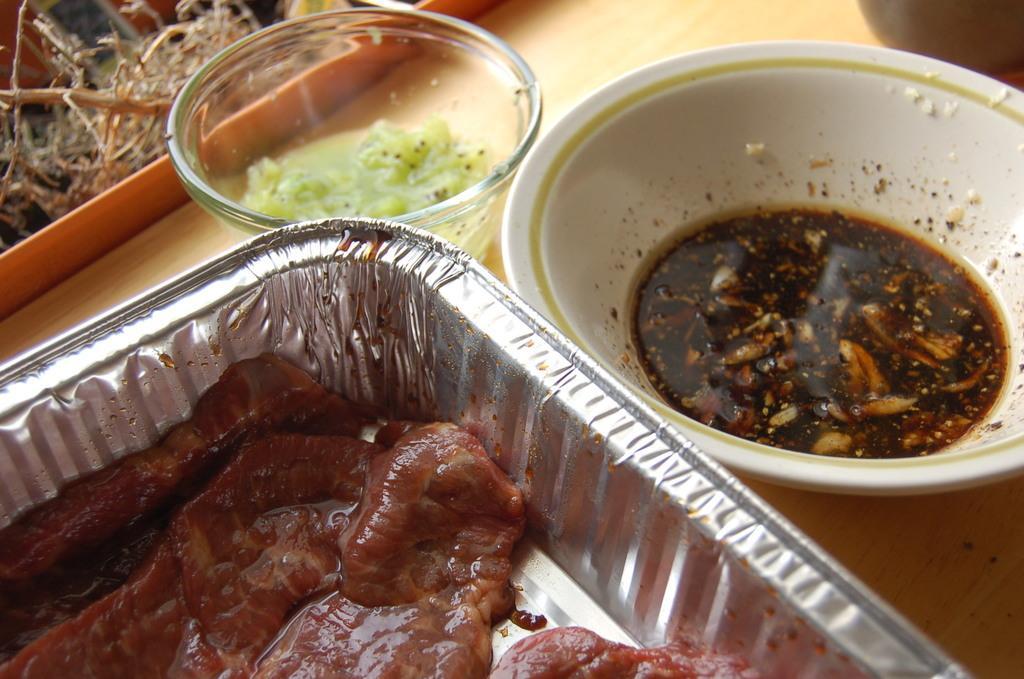Describe this image in one or two sentences. In this picture we can see bowls with food items in it and these bowls are placed on a table. 